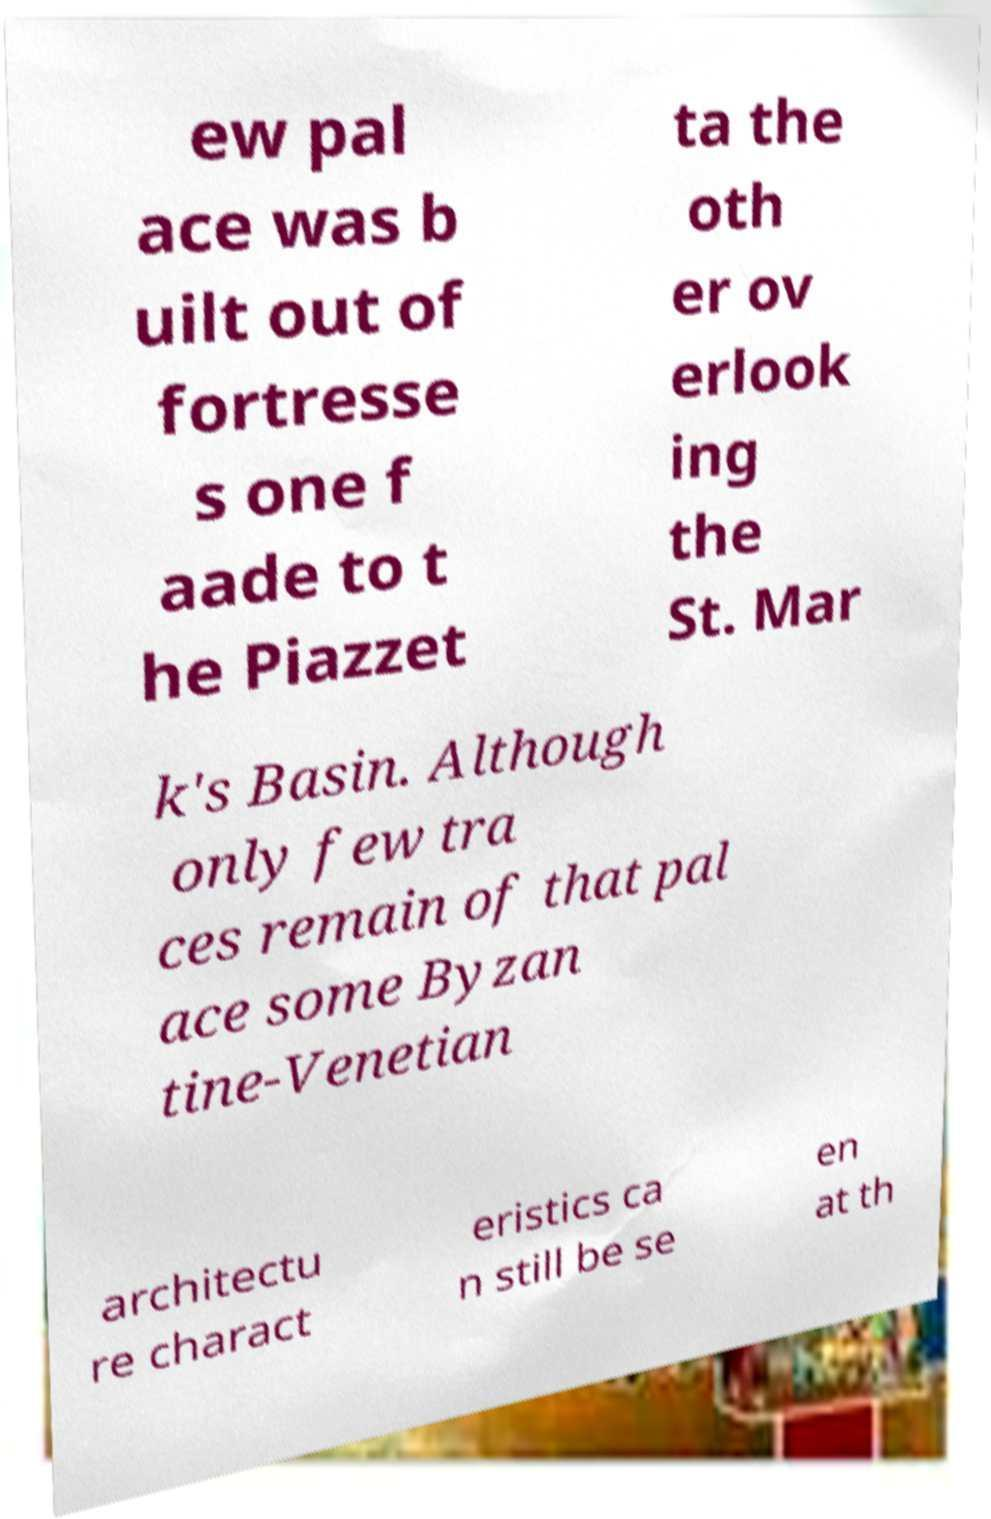Please read and relay the text visible in this image. What does it say? ew pal ace was b uilt out of fortresse s one f aade to t he Piazzet ta the oth er ov erlook ing the St. Mar k's Basin. Although only few tra ces remain of that pal ace some Byzan tine-Venetian architectu re charact eristics ca n still be se en at th 